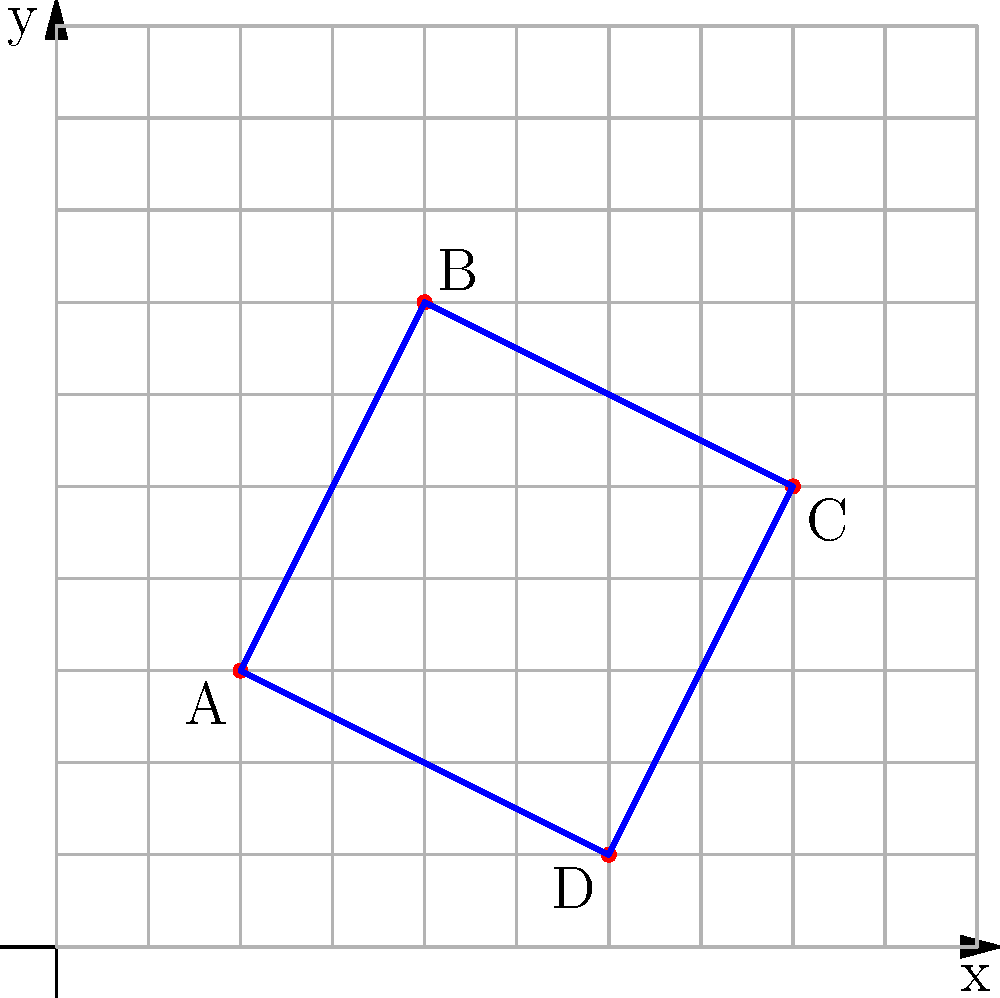As a concerned resident of Eugene, Oregon, you're reviewing a proposal to optimize school bus routes. The diagram shows four schools (A, B, C, and D) plotted on a grid, where each unit represents 1 mile. The proposed route visits all schools and returns to the starting point. What is the total distance traveled in miles for this route, and how much could be saved annually if this optimization reduces the current route by 15%, assuming buses run 180 school days per year? To solve this problem, we'll follow these steps:

1. Calculate the distance between each pair of schools:
   AB: $\sqrt{(4-2)^2 + (7-3)^2} = \sqrt{20} = 2\sqrt{5}$ miles
   BC: $\sqrt{(8-4)^2 + (5-7)^2} = \sqrt{20} = 2\sqrt{5}$ miles
   CD: $\sqrt{(6-8)^2 + (1-5)^2} = \sqrt{20} = 2\sqrt{5}$ miles
   DA: $\sqrt{(2-6)^2 + (3-1)^2} = \sqrt{20} = 2\sqrt{5}$ miles

2. Sum up the total distance:
   Total distance = $2\sqrt{5} + 2\sqrt{5} + 2\sqrt{5} + 2\sqrt{5} = 8\sqrt{5}$ miles

3. Calculate the annual savings:
   Current annual distance = $8\sqrt{5} \times 180 = 1440\sqrt{5}$ miles
   Reduction = 15% of $1440\sqrt{5} = 0.15 \times 1440\sqrt{5} = 216\sqrt{5}$ miles

Therefore, the total distance traveled per day is $8\sqrt{5}$ miles (approximately 17.89 miles), and the annual savings would be $216\sqrt{5}$ miles (approximately 482.93 miles).
Answer: $8\sqrt{5}$ miles per day; $216\sqrt{5}$ miles saved annually 